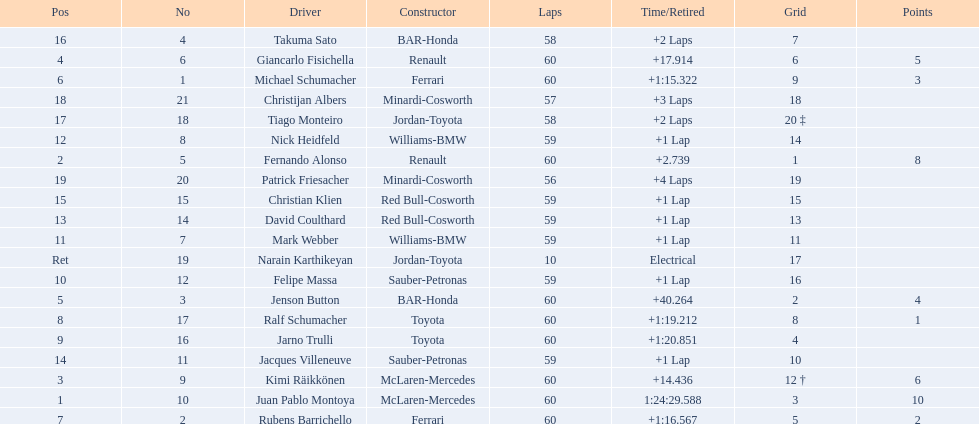Which driver has the least amount of points? Ralf Schumacher. 